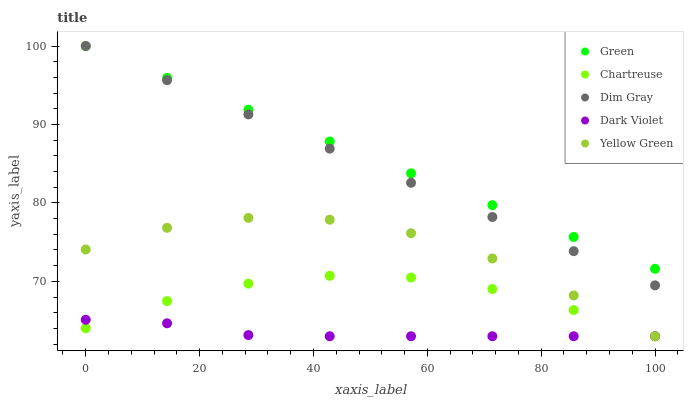Does Dark Violet have the minimum area under the curve?
Answer yes or no. Yes. Does Green have the maximum area under the curve?
Answer yes or no. Yes. Does Dim Gray have the minimum area under the curve?
Answer yes or no. No. Does Dim Gray have the maximum area under the curve?
Answer yes or no. No. Is Dim Gray the smoothest?
Answer yes or no. Yes. Is Yellow Green the roughest?
Answer yes or no. Yes. Is Green the smoothest?
Answer yes or no. No. Is Green the roughest?
Answer yes or no. No. Does Chartreuse have the lowest value?
Answer yes or no. Yes. Does Dim Gray have the lowest value?
Answer yes or no. No. Does Green have the highest value?
Answer yes or no. Yes. Does Yellow Green have the highest value?
Answer yes or no. No. Is Chartreuse less than Dim Gray?
Answer yes or no. Yes. Is Dim Gray greater than Chartreuse?
Answer yes or no. Yes. Does Dark Violet intersect Yellow Green?
Answer yes or no. Yes. Is Dark Violet less than Yellow Green?
Answer yes or no. No. Is Dark Violet greater than Yellow Green?
Answer yes or no. No. Does Chartreuse intersect Dim Gray?
Answer yes or no. No. 